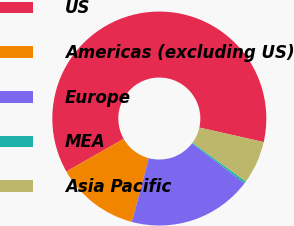<chart> <loc_0><loc_0><loc_500><loc_500><pie_chart><fcel>US<fcel>Americas (excluding US)<fcel>Europe<fcel>MEA<fcel>Asia Pacific<nl><fcel>61.77%<fcel>12.63%<fcel>18.77%<fcel>0.34%<fcel>6.48%<nl></chart> 